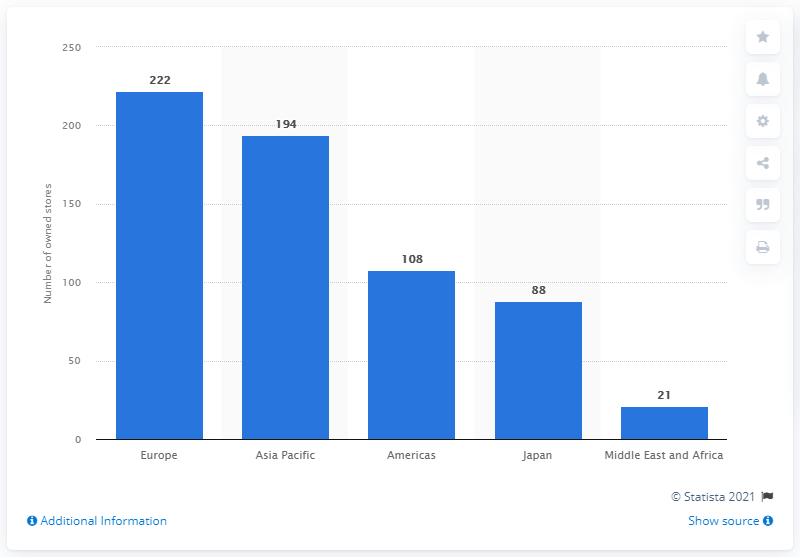Specify some key components in this picture. Prada had 222 Directly Operated Stores located in Europe in 2020. 